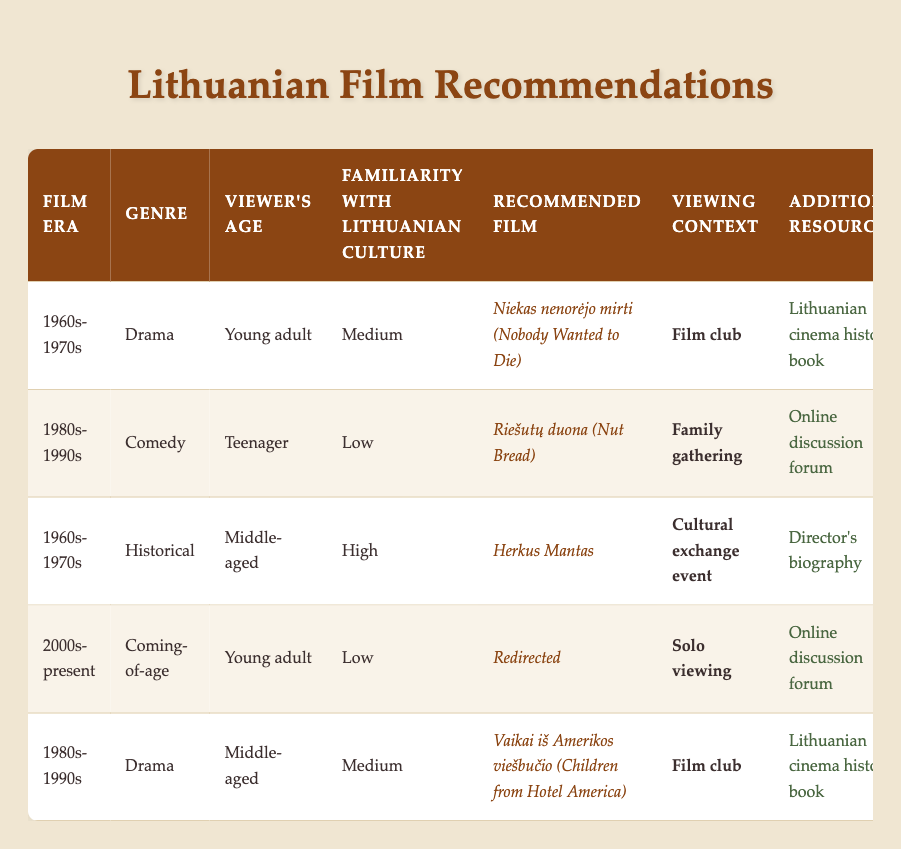What is the recommended film for young adults with medium familiarity with Lithuanian culture from the 1960s-1970s? The table shows that for young adults with medium familiarity with Lithuanian culture in the 1960s-1970s, the recommended film is "Niekas nenorėjo mirti (Nobody Wanted to Die)".
Answer: Niekas nenorėjo mirti (Nobody Wanted to Die) Is there a comedy film recommended for teenagers with low familiarity with Lithuanian culture? The table indicates that the recommended comedy film for teenagers with low familiarity with Lithuanian culture is "Riešutų duona (Nut Bread)", confirming that such a recommendation exists.
Answer: Yes What film is suggested for middle-aged viewers who are highly familiar with Lithuanian culture during the 1960s-1970s? According to the table, the suggested film for middle-aged viewers with high familiarity with Lithuanian culture from the 1960s-1970s is "Herkus Mantas".
Answer: Herkus Mantas For young adults with low familiarity with culture, which film is recommended for solo viewing? The table specifies that the recommended film for young adults with low familiarity with Lithuanian culture, suitable for solo viewing, is "Redirected".
Answer: Redirected How many films are recommended for each age group (teenager, young adult, middle-aged)? By reviewing the table, "Teenager" has 1 film ("Riešutų duona"), "Young adult" has 3 films ("Niekas nenorėjo mirti", "Redirected"), and "Middle-aged" has 2 films ("Herkus Mantas", "Vaikai iš Amerikos viešbučio"). Therefore, the total counts are: Teenager - 1, Young adult - 3, Middle-aged - 2.
Answer: Teenager - 1, Young adult - 3, Middle-aged - 2 Are there any films recommended for teenagers during the 2000s-present? After examining the table, it shows that there are no entries for teenagers during the 2000s-present. Therefore, the answer is no.
Answer: No 